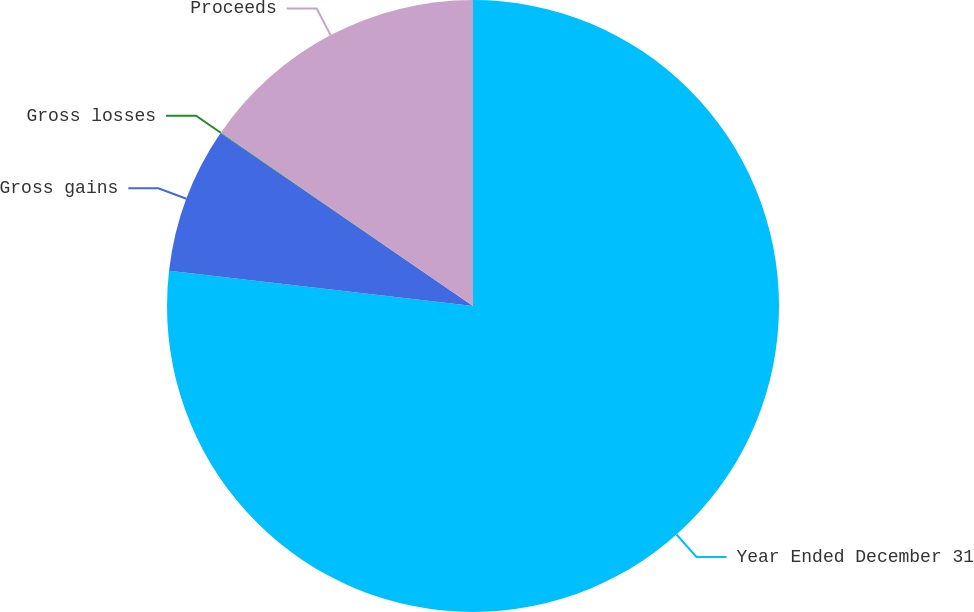Convert chart. <chart><loc_0><loc_0><loc_500><loc_500><pie_chart><fcel>Year Ended December 31<fcel>Gross gains<fcel>Gross losses<fcel>Proceeds<nl><fcel>76.84%<fcel>7.72%<fcel>0.04%<fcel>15.4%<nl></chart> 